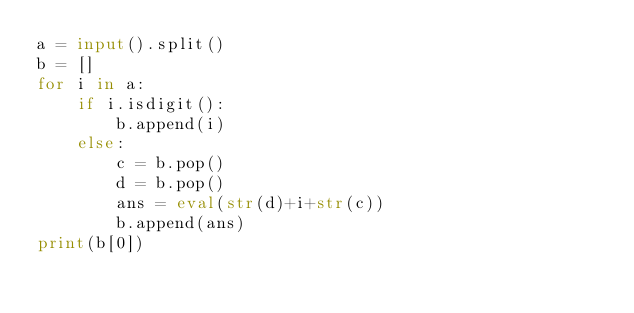Convert code to text. <code><loc_0><loc_0><loc_500><loc_500><_Python_>a = input().split()
b = []
for i in a:
    if i.isdigit():
        b.append(i)
    else:
        c = b.pop()
        d = b.pop()
        ans = eval(str(d)+i+str(c))
        b.append(ans)
print(b[0])

</code> 